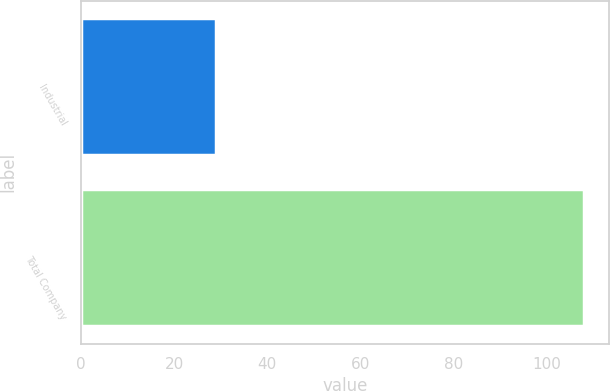<chart> <loc_0><loc_0><loc_500><loc_500><bar_chart><fcel>Industrial<fcel>Total Company<nl><fcel>29<fcel>108<nl></chart> 